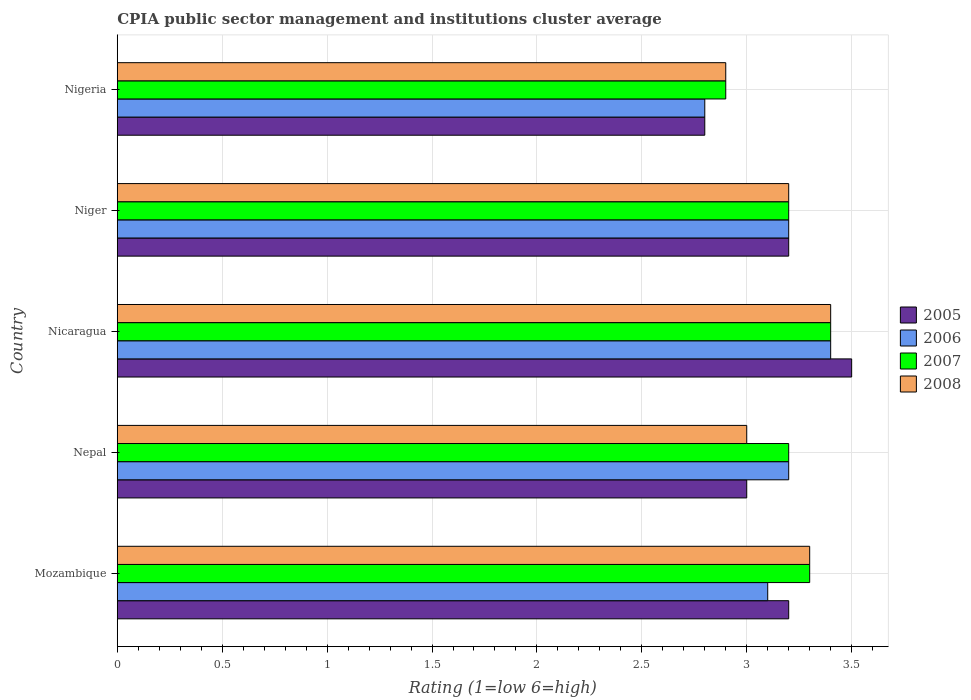How many bars are there on the 3rd tick from the top?
Make the answer very short. 4. What is the label of the 2nd group of bars from the top?
Make the answer very short. Niger. In how many cases, is the number of bars for a given country not equal to the number of legend labels?
Provide a succinct answer. 0. What is the CPIA rating in 2007 in Nepal?
Your response must be concise. 3.2. In which country was the CPIA rating in 2005 maximum?
Offer a very short reply. Nicaragua. In which country was the CPIA rating in 2005 minimum?
Your response must be concise. Nigeria. What is the total CPIA rating in 2006 in the graph?
Provide a succinct answer. 15.7. What is the difference between the CPIA rating in 2005 in Niger and that in Nigeria?
Your answer should be compact. 0.4. What is the difference between the CPIA rating in 2006 in Nicaragua and the CPIA rating in 2005 in Nepal?
Your answer should be very brief. 0.4. What is the average CPIA rating in 2006 per country?
Your answer should be very brief. 3.14. What is the difference between the CPIA rating in 2007 and CPIA rating in 2005 in Nigeria?
Make the answer very short. 0.1. Is the difference between the CPIA rating in 2007 in Mozambique and Niger greater than the difference between the CPIA rating in 2005 in Mozambique and Niger?
Your response must be concise. Yes. What is the difference between the highest and the second highest CPIA rating in 2008?
Your response must be concise. 0.1. In how many countries, is the CPIA rating in 2005 greater than the average CPIA rating in 2005 taken over all countries?
Give a very brief answer. 3. Is the sum of the CPIA rating in 2007 in Nicaragua and Nigeria greater than the maximum CPIA rating in 2008 across all countries?
Your answer should be very brief. Yes. Is it the case that in every country, the sum of the CPIA rating in 2008 and CPIA rating in 2005 is greater than the sum of CPIA rating in 2007 and CPIA rating in 2006?
Ensure brevity in your answer.  No. How many bars are there?
Offer a very short reply. 20. Are all the bars in the graph horizontal?
Make the answer very short. Yes. How many countries are there in the graph?
Your answer should be compact. 5. Are the values on the major ticks of X-axis written in scientific E-notation?
Provide a succinct answer. No. Where does the legend appear in the graph?
Make the answer very short. Center right. How many legend labels are there?
Give a very brief answer. 4. How are the legend labels stacked?
Offer a very short reply. Vertical. What is the title of the graph?
Provide a succinct answer. CPIA public sector management and institutions cluster average. Does "2005" appear as one of the legend labels in the graph?
Provide a succinct answer. Yes. What is the Rating (1=low 6=high) in 2005 in Mozambique?
Your response must be concise. 3.2. What is the Rating (1=low 6=high) in 2006 in Mozambique?
Provide a short and direct response. 3.1. What is the Rating (1=low 6=high) in 2007 in Mozambique?
Your response must be concise. 3.3. What is the Rating (1=low 6=high) of 2008 in Mozambique?
Your response must be concise. 3.3. What is the Rating (1=low 6=high) of 2005 in Nicaragua?
Make the answer very short. 3.5. What is the Rating (1=low 6=high) of 2006 in Nicaragua?
Ensure brevity in your answer.  3.4. What is the Rating (1=low 6=high) in 2007 in Nicaragua?
Offer a very short reply. 3.4. What is the Rating (1=low 6=high) of 2005 in Niger?
Your answer should be compact. 3.2. What is the Rating (1=low 6=high) of 2007 in Niger?
Ensure brevity in your answer.  3.2. What is the Rating (1=low 6=high) in 2008 in Nigeria?
Offer a terse response. 2.9. Across all countries, what is the maximum Rating (1=low 6=high) of 2005?
Provide a short and direct response. 3.5. Across all countries, what is the maximum Rating (1=low 6=high) in 2006?
Provide a short and direct response. 3.4. Across all countries, what is the maximum Rating (1=low 6=high) of 2007?
Offer a terse response. 3.4. Across all countries, what is the minimum Rating (1=low 6=high) of 2005?
Provide a short and direct response. 2.8. What is the total Rating (1=low 6=high) of 2007 in the graph?
Offer a very short reply. 16. What is the difference between the Rating (1=low 6=high) in 2005 in Mozambique and that in Nepal?
Keep it short and to the point. 0.2. What is the difference between the Rating (1=low 6=high) in 2006 in Mozambique and that in Nepal?
Make the answer very short. -0.1. What is the difference between the Rating (1=low 6=high) of 2006 in Mozambique and that in Nicaragua?
Offer a terse response. -0.3. What is the difference between the Rating (1=low 6=high) of 2008 in Mozambique and that in Nicaragua?
Your answer should be very brief. -0.1. What is the difference between the Rating (1=low 6=high) of 2006 in Mozambique and that in Niger?
Ensure brevity in your answer.  -0.1. What is the difference between the Rating (1=low 6=high) of 2007 in Mozambique and that in Niger?
Make the answer very short. 0.1. What is the difference between the Rating (1=low 6=high) of 2005 in Mozambique and that in Nigeria?
Your answer should be compact. 0.4. What is the difference between the Rating (1=low 6=high) in 2006 in Mozambique and that in Nigeria?
Offer a terse response. 0.3. What is the difference between the Rating (1=low 6=high) in 2008 in Mozambique and that in Nigeria?
Keep it short and to the point. 0.4. What is the difference between the Rating (1=low 6=high) in 2005 in Nepal and that in Niger?
Your answer should be compact. -0.2. What is the difference between the Rating (1=low 6=high) in 2008 in Nepal and that in Niger?
Your answer should be very brief. -0.2. What is the difference between the Rating (1=low 6=high) of 2005 in Nicaragua and that in Niger?
Offer a very short reply. 0.3. What is the difference between the Rating (1=low 6=high) in 2006 in Nicaragua and that in Niger?
Offer a terse response. 0.2. What is the difference between the Rating (1=low 6=high) in 2008 in Nicaragua and that in Niger?
Your answer should be very brief. 0.2. What is the difference between the Rating (1=low 6=high) in 2005 in Nicaragua and that in Nigeria?
Make the answer very short. 0.7. What is the difference between the Rating (1=low 6=high) of 2007 in Nicaragua and that in Nigeria?
Your response must be concise. 0.5. What is the difference between the Rating (1=low 6=high) in 2006 in Niger and that in Nigeria?
Offer a very short reply. 0.4. What is the difference between the Rating (1=low 6=high) of 2007 in Niger and that in Nigeria?
Your answer should be very brief. 0.3. What is the difference between the Rating (1=low 6=high) of 2008 in Niger and that in Nigeria?
Your answer should be compact. 0.3. What is the difference between the Rating (1=low 6=high) in 2005 in Mozambique and the Rating (1=low 6=high) in 2006 in Nepal?
Offer a terse response. 0. What is the difference between the Rating (1=low 6=high) of 2005 in Mozambique and the Rating (1=low 6=high) of 2007 in Nepal?
Make the answer very short. 0. What is the difference between the Rating (1=low 6=high) of 2006 in Mozambique and the Rating (1=low 6=high) of 2007 in Nepal?
Ensure brevity in your answer.  -0.1. What is the difference between the Rating (1=low 6=high) in 2006 in Mozambique and the Rating (1=low 6=high) in 2008 in Nepal?
Offer a very short reply. 0.1. What is the difference between the Rating (1=low 6=high) in 2007 in Mozambique and the Rating (1=low 6=high) in 2008 in Nepal?
Your answer should be very brief. 0.3. What is the difference between the Rating (1=low 6=high) of 2005 in Mozambique and the Rating (1=low 6=high) of 2007 in Nicaragua?
Offer a terse response. -0.2. What is the difference between the Rating (1=low 6=high) in 2006 in Mozambique and the Rating (1=low 6=high) in 2007 in Nicaragua?
Your response must be concise. -0.3. What is the difference between the Rating (1=low 6=high) of 2006 in Mozambique and the Rating (1=low 6=high) of 2008 in Nicaragua?
Offer a very short reply. -0.3. What is the difference between the Rating (1=low 6=high) in 2007 in Mozambique and the Rating (1=low 6=high) in 2008 in Nicaragua?
Your response must be concise. -0.1. What is the difference between the Rating (1=low 6=high) in 2006 in Mozambique and the Rating (1=low 6=high) in 2007 in Niger?
Your answer should be compact. -0.1. What is the difference between the Rating (1=low 6=high) in 2006 in Mozambique and the Rating (1=low 6=high) in 2008 in Niger?
Offer a very short reply. -0.1. What is the difference between the Rating (1=low 6=high) of 2005 in Mozambique and the Rating (1=low 6=high) of 2006 in Nigeria?
Ensure brevity in your answer.  0.4. What is the difference between the Rating (1=low 6=high) in 2006 in Mozambique and the Rating (1=low 6=high) in 2008 in Nigeria?
Make the answer very short. 0.2. What is the difference between the Rating (1=low 6=high) in 2005 in Nepal and the Rating (1=low 6=high) in 2006 in Nicaragua?
Give a very brief answer. -0.4. What is the difference between the Rating (1=low 6=high) in 2005 in Nepal and the Rating (1=low 6=high) in 2007 in Nicaragua?
Give a very brief answer. -0.4. What is the difference between the Rating (1=low 6=high) of 2006 in Nepal and the Rating (1=low 6=high) of 2008 in Nicaragua?
Your answer should be compact. -0.2. What is the difference between the Rating (1=low 6=high) of 2007 in Nepal and the Rating (1=low 6=high) of 2008 in Nicaragua?
Offer a very short reply. -0.2. What is the difference between the Rating (1=low 6=high) in 2005 in Nepal and the Rating (1=low 6=high) in 2006 in Niger?
Your answer should be very brief. -0.2. What is the difference between the Rating (1=low 6=high) of 2006 in Nepal and the Rating (1=low 6=high) of 2008 in Niger?
Your response must be concise. 0. What is the difference between the Rating (1=low 6=high) in 2005 in Nepal and the Rating (1=low 6=high) in 2006 in Nigeria?
Offer a terse response. 0.2. What is the difference between the Rating (1=low 6=high) of 2007 in Nepal and the Rating (1=low 6=high) of 2008 in Nigeria?
Your response must be concise. 0.3. What is the difference between the Rating (1=low 6=high) in 2005 in Nicaragua and the Rating (1=low 6=high) in 2008 in Niger?
Provide a short and direct response. 0.3. What is the difference between the Rating (1=low 6=high) in 2006 in Nicaragua and the Rating (1=low 6=high) in 2008 in Niger?
Offer a terse response. 0.2. What is the difference between the Rating (1=low 6=high) in 2005 in Nicaragua and the Rating (1=low 6=high) in 2006 in Nigeria?
Provide a short and direct response. 0.7. What is the difference between the Rating (1=low 6=high) in 2007 in Nicaragua and the Rating (1=low 6=high) in 2008 in Nigeria?
Give a very brief answer. 0.5. What is the difference between the Rating (1=low 6=high) in 2005 in Niger and the Rating (1=low 6=high) in 2008 in Nigeria?
Your answer should be compact. 0.3. What is the difference between the Rating (1=low 6=high) in 2006 in Niger and the Rating (1=low 6=high) in 2007 in Nigeria?
Ensure brevity in your answer.  0.3. What is the difference between the Rating (1=low 6=high) in 2007 in Niger and the Rating (1=low 6=high) in 2008 in Nigeria?
Provide a succinct answer. 0.3. What is the average Rating (1=low 6=high) in 2005 per country?
Ensure brevity in your answer.  3.14. What is the average Rating (1=low 6=high) of 2006 per country?
Keep it short and to the point. 3.14. What is the average Rating (1=low 6=high) of 2007 per country?
Provide a succinct answer. 3.2. What is the average Rating (1=low 6=high) in 2008 per country?
Your answer should be very brief. 3.16. What is the difference between the Rating (1=low 6=high) in 2005 and Rating (1=low 6=high) in 2006 in Mozambique?
Provide a short and direct response. 0.1. What is the difference between the Rating (1=low 6=high) of 2005 and Rating (1=low 6=high) of 2008 in Mozambique?
Offer a terse response. -0.1. What is the difference between the Rating (1=low 6=high) of 2006 and Rating (1=low 6=high) of 2008 in Mozambique?
Your response must be concise. -0.2. What is the difference between the Rating (1=low 6=high) in 2007 and Rating (1=low 6=high) in 2008 in Mozambique?
Your answer should be compact. 0. What is the difference between the Rating (1=low 6=high) in 2006 and Rating (1=low 6=high) in 2007 in Nepal?
Your answer should be very brief. 0. What is the difference between the Rating (1=low 6=high) of 2006 and Rating (1=low 6=high) of 2008 in Nepal?
Offer a terse response. 0.2. What is the difference between the Rating (1=low 6=high) of 2007 and Rating (1=low 6=high) of 2008 in Nepal?
Keep it short and to the point. 0.2. What is the difference between the Rating (1=low 6=high) of 2005 and Rating (1=low 6=high) of 2007 in Nicaragua?
Offer a terse response. 0.1. What is the difference between the Rating (1=low 6=high) in 2006 and Rating (1=low 6=high) in 2007 in Nicaragua?
Offer a very short reply. 0. What is the difference between the Rating (1=low 6=high) in 2006 and Rating (1=low 6=high) in 2008 in Nicaragua?
Your response must be concise. 0. What is the difference between the Rating (1=low 6=high) in 2006 and Rating (1=low 6=high) in 2007 in Niger?
Your answer should be very brief. 0. What is the difference between the Rating (1=low 6=high) in 2005 and Rating (1=low 6=high) in 2007 in Nigeria?
Your response must be concise. -0.1. What is the difference between the Rating (1=low 6=high) in 2005 and Rating (1=low 6=high) in 2008 in Nigeria?
Offer a very short reply. -0.1. What is the difference between the Rating (1=low 6=high) of 2006 and Rating (1=low 6=high) of 2007 in Nigeria?
Make the answer very short. -0.1. What is the ratio of the Rating (1=low 6=high) in 2005 in Mozambique to that in Nepal?
Offer a very short reply. 1.07. What is the ratio of the Rating (1=low 6=high) of 2006 in Mozambique to that in Nepal?
Keep it short and to the point. 0.97. What is the ratio of the Rating (1=low 6=high) in 2007 in Mozambique to that in Nepal?
Your answer should be compact. 1.03. What is the ratio of the Rating (1=low 6=high) in 2008 in Mozambique to that in Nepal?
Offer a terse response. 1.1. What is the ratio of the Rating (1=low 6=high) of 2005 in Mozambique to that in Nicaragua?
Ensure brevity in your answer.  0.91. What is the ratio of the Rating (1=low 6=high) of 2006 in Mozambique to that in Nicaragua?
Keep it short and to the point. 0.91. What is the ratio of the Rating (1=low 6=high) in 2007 in Mozambique to that in Nicaragua?
Provide a short and direct response. 0.97. What is the ratio of the Rating (1=low 6=high) of 2008 in Mozambique to that in Nicaragua?
Your answer should be compact. 0.97. What is the ratio of the Rating (1=low 6=high) of 2005 in Mozambique to that in Niger?
Your answer should be very brief. 1. What is the ratio of the Rating (1=low 6=high) in 2006 in Mozambique to that in Niger?
Make the answer very short. 0.97. What is the ratio of the Rating (1=low 6=high) of 2007 in Mozambique to that in Niger?
Your answer should be compact. 1.03. What is the ratio of the Rating (1=low 6=high) of 2008 in Mozambique to that in Niger?
Offer a terse response. 1.03. What is the ratio of the Rating (1=low 6=high) in 2006 in Mozambique to that in Nigeria?
Ensure brevity in your answer.  1.11. What is the ratio of the Rating (1=low 6=high) of 2007 in Mozambique to that in Nigeria?
Offer a very short reply. 1.14. What is the ratio of the Rating (1=low 6=high) in 2008 in Mozambique to that in Nigeria?
Your answer should be very brief. 1.14. What is the ratio of the Rating (1=low 6=high) in 2006 in Nepal to that in Nicaragua?
Ensure brevity in your answer.  0.94. What is the ratio of the Rating (1=low 6=high) in 2007 in Nepal to that in Nicaragua?
Your response must be concise. 0.94. What is the ratio of the Rating (1=low 6=high) of 2008 in Nepal to that in Nicaragua?
Your answer should be very brief. 0.88. What is the ratio of the Rating (1=low 6=high) of 2005 in Nepal to that in Niger?
Your answer should be compact. 0.94. What is the ratio of the Rating (1=low 6=high) of 2007 in Nepal to that in Niger?
Provide a succinct answer. 1. What is the ratio of the Rating (1=low 6=high) of 2008 in Nepal to that in Niger?
Provide a short and direct response. 0.94. What is the ratio of the Rating (1=low 6=high) of 2005 in Nepal to that in Nigeria?
Offer a very short reply. 1.07. What is the ratio of the Rating (1=low 6=high) in 2007 in Nepal to that in Nigeria?
Your answer should be compact. 1.1. What is the ratio of the Rating (1=low 6=high) of 2008 in Nepal to that in Nigeria?
Make the answer very short. 1.03. What is the ratio of the Rating (1=low 6=high) in 2005 in Nicaragua to that in Niger?
Ensure brevity in your answer.  1.09. What is the ratio of the Rating (1=low 6=high) in 2006 in Nicaragua to that in Niger?
Offer a very short reply. 1.06. What is the ratio of the Rating (1=low 6=high) in 2008 in Nicaragua to that in Niger?
Ensure brevity in your answer.  1.06. What is the ratio of the Rating (1=low 6=high) in 2006 in Nicaragua to that in Nigeria?
Your answer should be very brief. 1.21. What is the ratio of the Rating (1=low 6=high) in 2007 in Nicaragua to that in Nigeria?
Give a very brief answer. 1.17. What is the ratio of the Rating (1=low 6=high) of 2008 in Nicaragua to that in Nigeria?
Your answer should be compact. 1.17. What is the ratio of the Rating (1=low 6=high) of 2007 in Niger to that in Nigeria?
Offer a very short reply. 1.1. What is the ratio of the Rating (1=low 6=high) of 2008 in Niger to that in Nigeria?
Provide a short and direct response. 1.1. What is the difference between the highest and the second highest Rating (1=low 6=high) of 2005?
Make the answer very short. 0.3. What is the difference between the highest and the lowest Rating (1=low 6=high) of 2006?
Make the answer very short. 0.6. What is the difference between the highest and the lowest Rating (1=low 6=high) of 2007?
Provide a short and direct response. 0.5. 